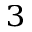<formula> <loc_0><loc_0><loc_500><loc_500>^ { 3 }</formula> 